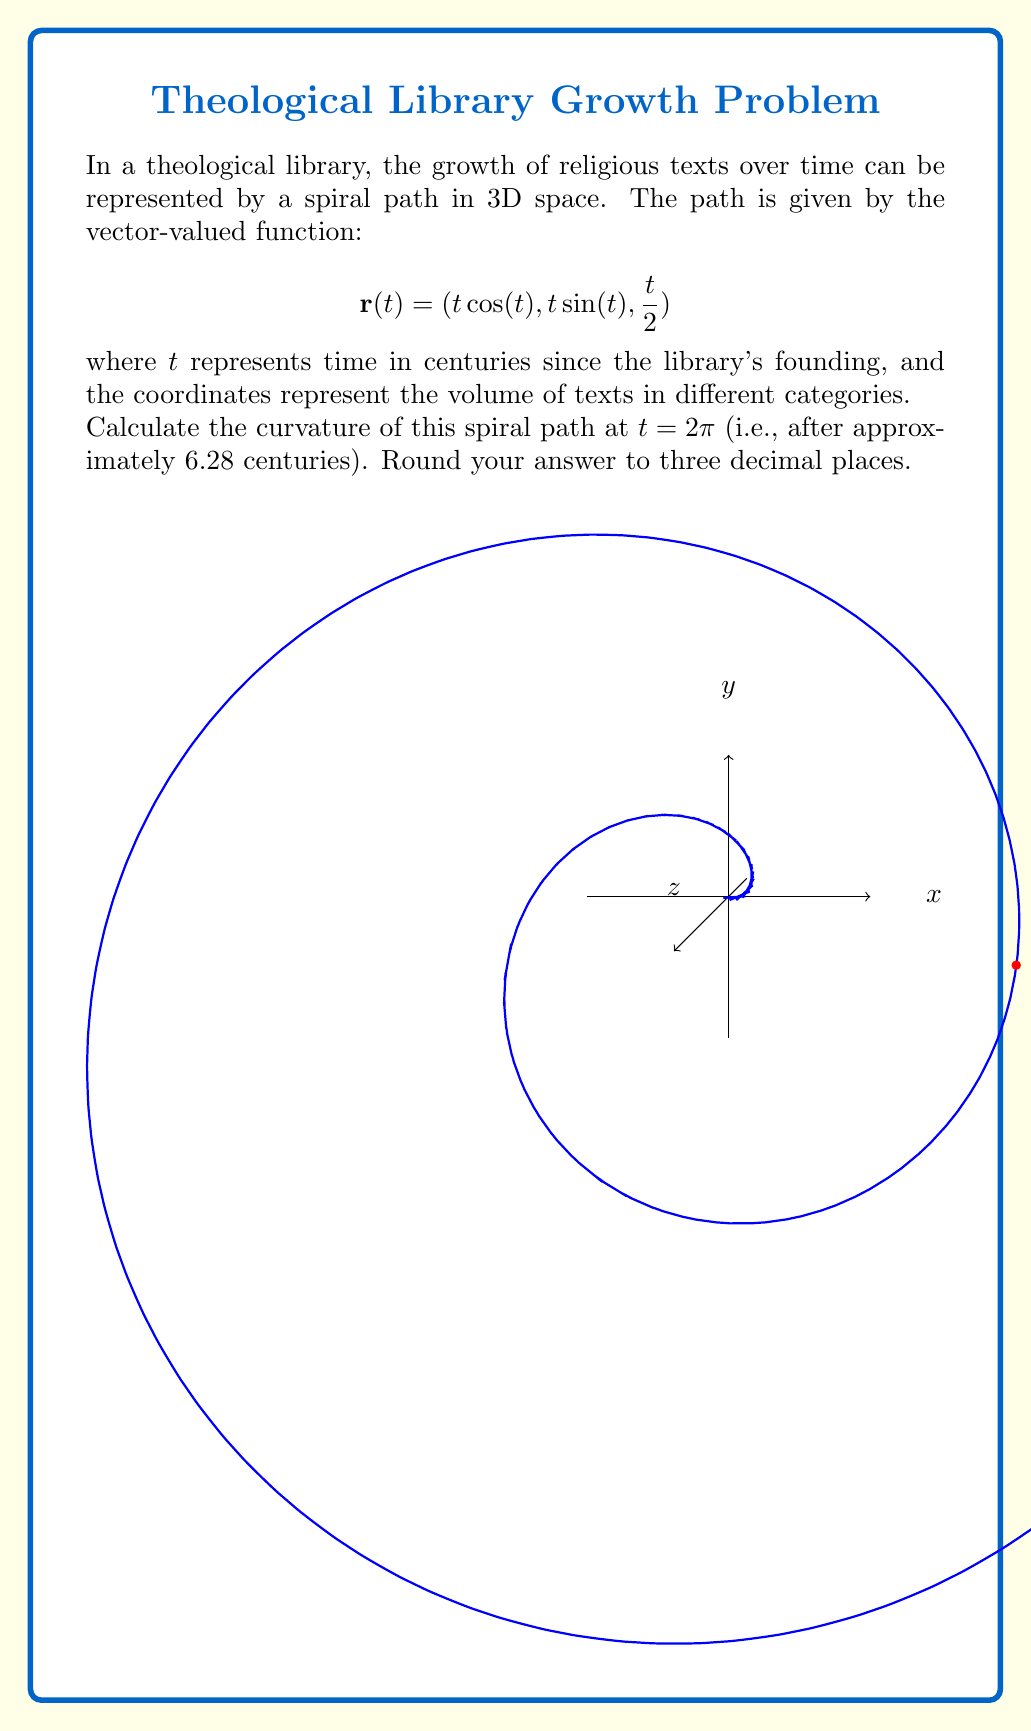Teach me how to tackle this problem. To find the curvature of the spiral path, we'll use the formula:

$$\kappa = \frac{|\mathbf{r}'(t) \times \mathbf{r}''(t)|}{|\mathbf{r}'(t)|^3}$$

Step 1: Calculate $\mathbf{r}'(t)$
$$\mathbf{r}'(t) = (\cos(t) - t\sin(t), \sin(t) + t\cos(t), \frac{1}{2})$$

Step 2: Calculate $\mathbf{r}''(t)$
$$\mathbf{r}''(t) = (-2\sin(t) - t\cos(t), 2\cos(t) - t\sin(t), 0)$$

Step 3: Evaluate $\mathbf{r}'(2\pi)$ and $\mathbf{r}''(2\pi)$
$$\mathbf{r}'(2\pi) = (1, 2\pi, \frac{1}{2})$$
$$\mathbf{r}''(2\pi) = (-2\pi, -1, 0)$$

Step 4: Calculate $\mathbf{r}'(2\pi) \times \mathbf{r}''(2\pi)$
$$\mathbf{r}'(2\pi) \times \mathbf{r}''(2\pi) = \begin{vmatrix} 
\mathbf{i} & \mathbf{j} & \mathbf{k} \\
1 & 2\pi & \frac{1}{2} \\
-2\pi & -1 & 0
\end{vmatrix} = (-\frac{1}{2}, -\pi, 4\pi^2-1)$$

Step 5: Calculate $|\mathbf{r}'(2\pi) \times \mathbf{r}''(2\pi)|$
$$|\mathbf{r}'(2\pi) \times \mathbf{r}''(2\pi)| = \sqrt{(-\frac{1}{2})^2 + (-\pi)^2 + (4\pi^2-1)^2} \approx 39.4784$$

Step 6: Calculate $|\mathbf{r}'(2\pi)|$
$$|\mathbf{r}'(2\pi)| = \sqrt{1^2 + (2\pi)^2 + (\frac{1}{2})^2} \approx 6.2842$$

Step 7: Apply the curvature formula
$$\kappa = \frac{39.4784}{6.2842^3} \approx 0.159$$

Therefore, the curvature of the spiral path at $t = 2\pi$ is approximately 0.159.
Answer: 0.159 